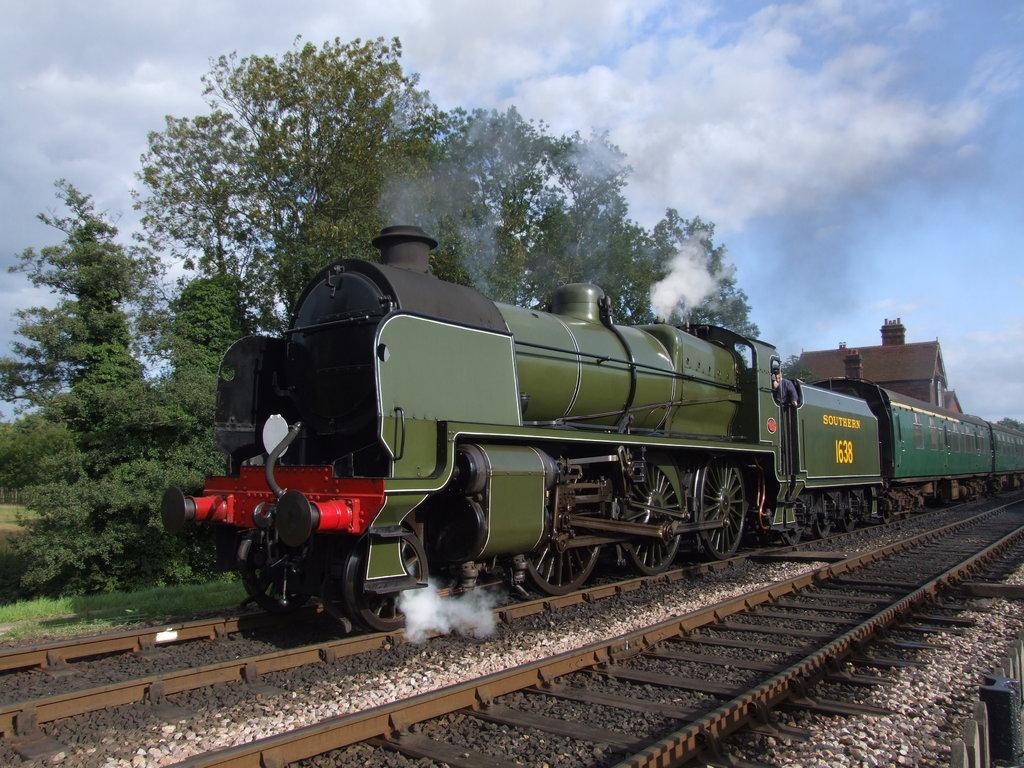What is the main subject of the image? There is a train in the image. Where is the train located? The train is on a train track. What type of terrain can be seen in the image? There are stones, grass, and trees visible in the image. What is the condition of the sky in the image? The sky is cloudy in the image. What can be seen coming from the train in the image? There is smoke visible in the image. Can you tell me how many volleyballs are visible in the image? There are no volleyballs present in the image. What type of bead is used to decorate the train in the image? There is no bead used to decorate the train in the image. 